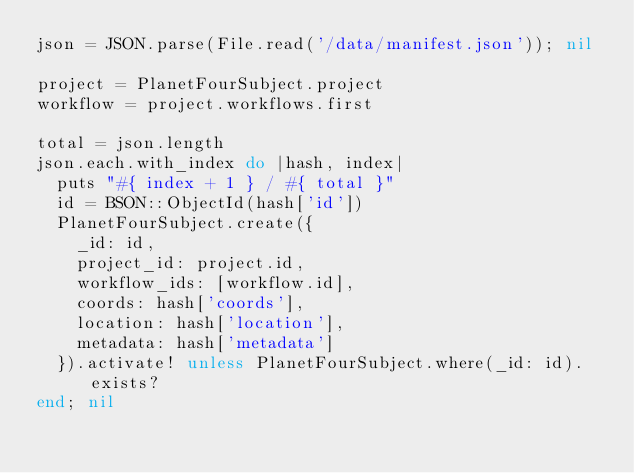<code> <loc_0><loc_0><loc_500><loc_500><_Ruby_>json = JSON.parse(File.read('/data/manifest.json')); nil

project = PlanetFourSubject.project
workflow = project.workflows.first

total = json.length
json.each.with_index do |hash, index|
  puts "#{ index + 1 } / #{ total }"
  id = BSON::ObjectId(hash['id'])
  PlanetFourSubject.create({
    _id: id,
    project_id: project.id,
    workflow_ids: [workflow.id],
    coords: hash['coords'],
    location: hash['location'],
    metadata: hash['metadata']
  }).activate! unless PlanetFourSubject.where(_id: id).exists?
end; nil
</code> 